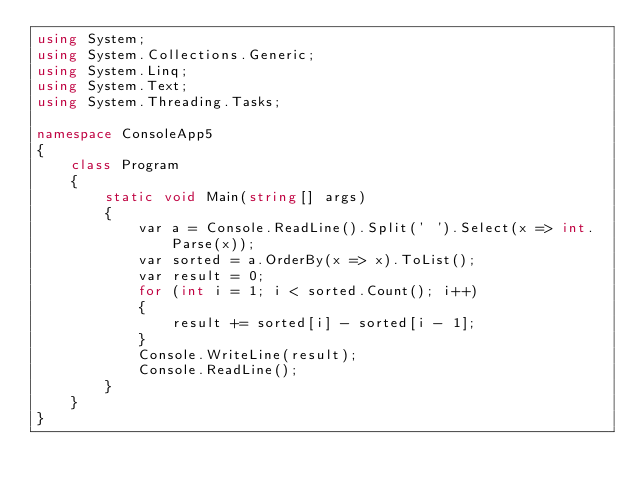Convert code to text. <code><loc_0><loc_0><loc_500><loc_500><_C#_>using System;
using System.Collections.Generic;
using System.Linq;
using System.Text;
using System.Threading.Tasks;

namespace ConsoleApp5
{
    class Program
    {
        static void Main(string[] args)
        {
            var a = Console.ReadLine().Split(' ').Select(x => int.Parse(x));
            var sorted = a.OrderBy(x => x).ToList();
            var result = 0;
            for (int i = 1; i < sorted.Count(); i++)
            {
                result += sorted[i] - sorted[i - 1];
            }
            Console.WriteLine(result);
            Console.ReadLine();
        }
    }
}
</code> 